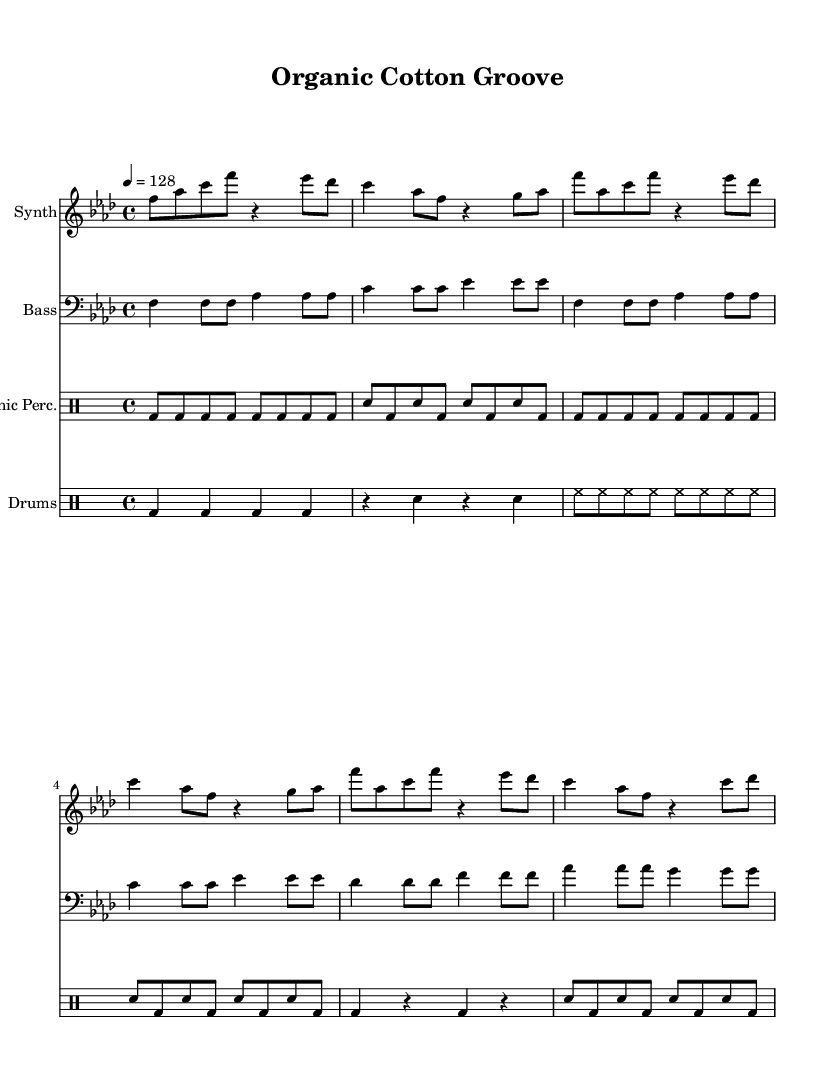What is the key signature of this music? The key signature is F minor, which corresponds to the three flats shown in the key signature indication on the staff.
Answer: F minor What is the time signature of this piece? The time signature is indicated as 4/4, meaning there are four beats in each measure and the quarter note receives one beat.
Answer: 4/4 What is the tempo marking for this track? The tempo marking indicates a speed of 128 beats per minute, as shown next to the tempo indication at the beginning of the score.
Answer: 128 How many measures are in the main section of the piece? The main section consists of 8 measures in total, as counted in the synth staff where the repeated patterns occur and match the notation for the main section.
Answer: 8 What types of percussion are used in the organic percussion section? The organic percussion section comprises bass drum (bd) and snare drum (sn), which are denoted in the drummode staff of the organic percussion part.
Answer: Bass drum, snare drum Which instrument plays the melodic line in this piece? The melodic line is played by the synth, as indicated by its separate staff labeled "Synth" at the beginning of the score, showing the melodic material distinctly.
Answer: Synth What is the rhythmic pattern of the bass in the introduction? The rhythmic pattern features quarter notes followed by eighth notes, clearly indicated in the bass staff for the introductory 8 measures.
Answer: Quarter-eighth 